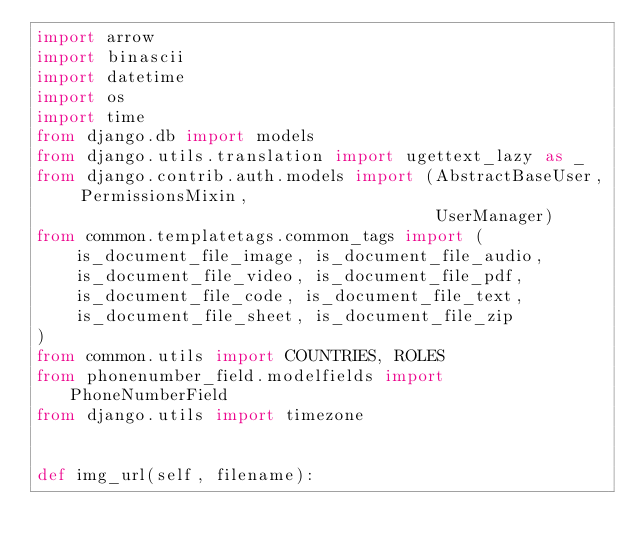Convert code to text. <code><loc_0><loc_0><loc_500><loc_500><_Python_>import arrow
import binascii
import datetime
import os
import time
from django.db import models
from django.utils.translation import ugettext_lazy as _
from django.contrib.auth.models import (AbstractBaseUser, PermissionsMixin,
                                        UserManager)
from common.templatetags.common_tags import (
    is_document_file_image, is_document_file_audio,
    is_document_file_video, is_document_file_pdf,
    is_document_file_code, is_document_file_text,
    is_document_file_sheet, is_document_file_zip
)
from common.utils import COUNTRIES, ROLES
from phonenumber_field.modelfields import PhoneNumberField
from django.utils import timezone


def img_url(self, filename):</code> 